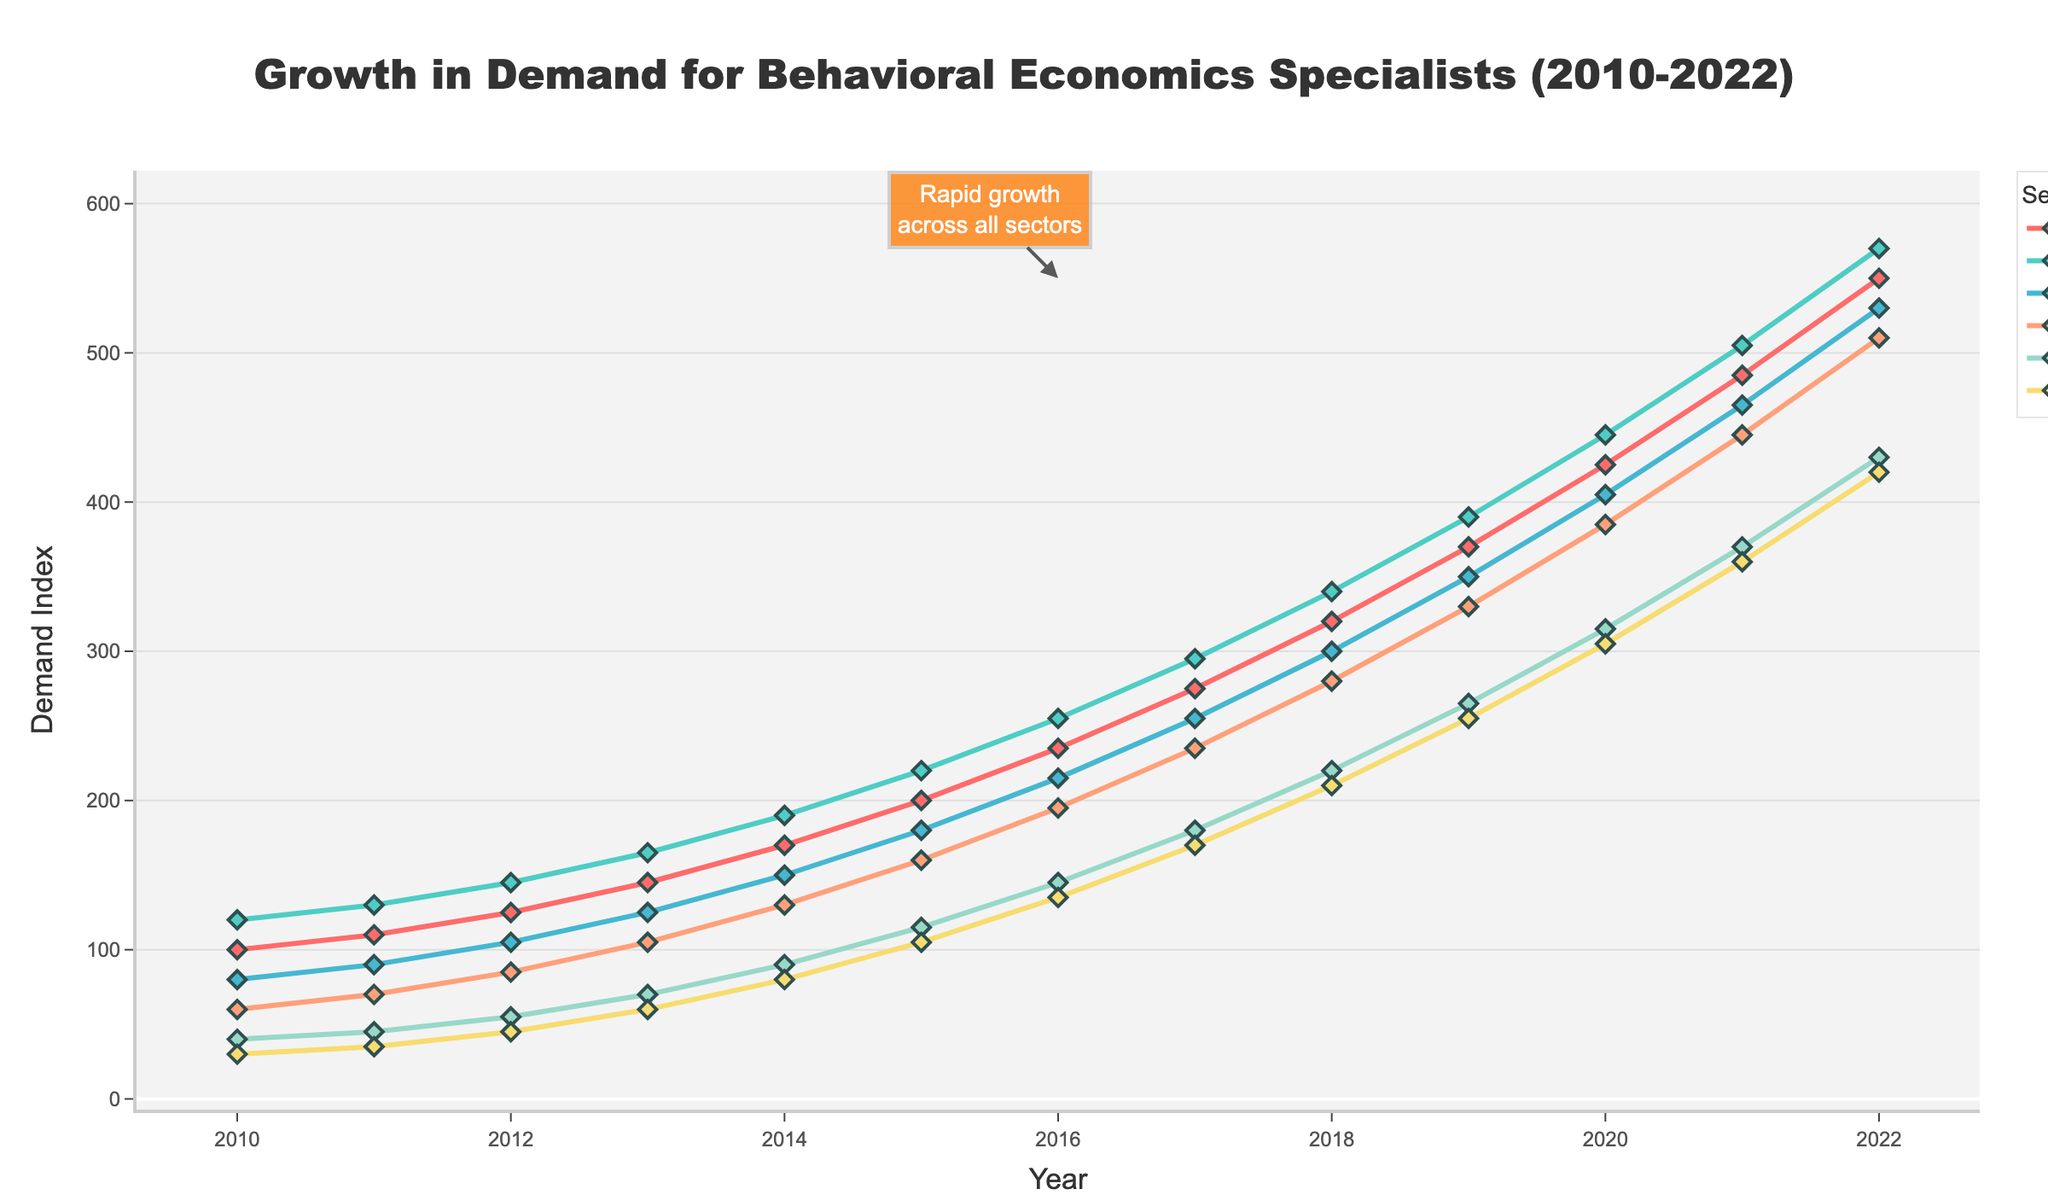What sector saw the highest demand in 2022? Look at the 2022 data point for all sectors. The sector with the highest value is Management Consulting.
Answer: Management Consulting What year did Corporate HR first surpass a demand index of 200? Find the year where the Corporate HR line first goes above 200. This happens in 2015.
Answer: 2015 How many years did it take for the Tech Industry demand index to go from 160 to 510? Find the years where the Tech Industry demand index first hits 160 and 510. The values corresponding to these thresholds are found in 2015 and 2022, respectively. So, it took 7 years.
Answer: 7 years Compare the demand for behavioral economics specialists in Financial Services and Healthcare in 2018. Which sector had higher demand and what is the difference? In 2018, the demand index for Financial Services is 300 and for Healthcare is 210. Financial Services had a higher demand. The difference is 300 - 210 = 90.
Answer: Financial Services, 90 What is the average demand index for Government Policy from 2010 to 2022? Sum all the Government Policy values from 2010 to 2022 and divide by the number of years (13). (40+45+55+70+90+115+145+180+220+265+315+370+430)/13 ≈ 185.38.
Answer: 185.38 Which sector showed the most consistent growth from 2010 to 2022? Examine the trend lines for all sectors. The lines that show the least fluctuation and steady increase represent consistent growth. All sectors show steady growth, but Healthcare appears the most linear and consistent.
Answer: Healthcare In what year did the rapid growth across all sectors begin, as indicated by the annotation? The annotation points to the year 2016 as the start of rapid growth across all sectors.
Answer: 2016 Compare the rate of growth between Corporate HR and Tech Industry from 2015 to 2020. Which had a higher percentage increase? Find the initial and final values of both sectors: Corporate HR (200 to 425), Tech Industry (160 to 385). Calculate the percentage increase for both sectors: Corporate HR ((425-200)/200) * 100% ≈ 112.5%, Tech Industry ((385-160)/160) * 100% ≈ 140.6%. Tech Industry had a higher percentage increase.
Answer: Tech Industry, 140.6% What was the difference in demand between Healthcare and Government Policy in 2022? Find the values for both sectors in 2022: Healthcare (420) and Government Policy (430). Calculate the difference: 430 - 420 = 10.
Answer: 10 Which sector had the least demand growth from 2010 to 2013? Compare the growth in demand between 2010 and 2013 for each sector. The differences are: Corporate HR (45), Management Consulting (45), Financial Services (45), Tech Industry (45), Government Policy (30), Healthcare (30). Healthcare and Government Policy had the least growth.
Answer: Healthcare, Government Policy 